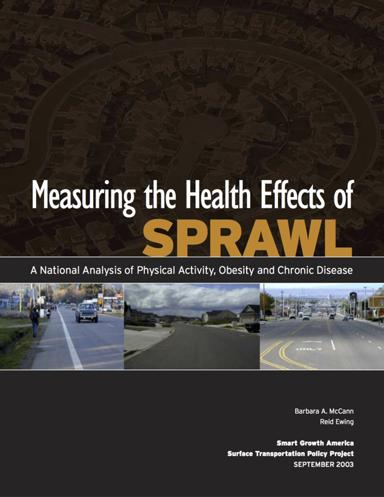Can you tell me more about 'Smart Growth America' and what they stand for? Smart Growth America advocates for urban development that supports healthy, resilient, and economically sustainable communities. They promote integrated approaches that protect the environment and enhance quality of life. 